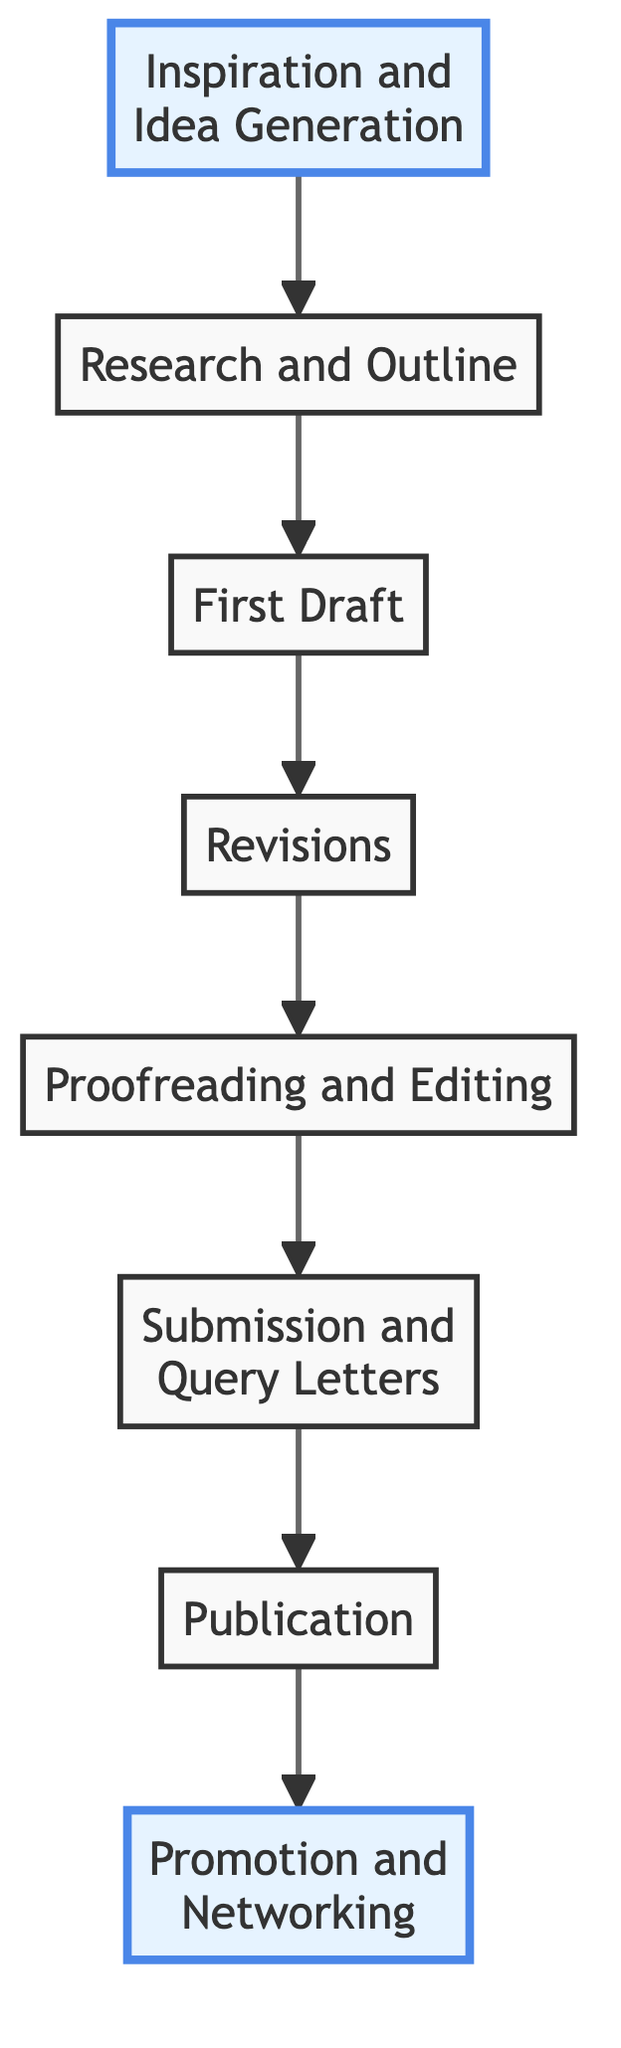What is the first step in the writing project process? The first step in the diagram is "Inspiration and Idea Generation." It is the topmost element, indicating the starting point of the writing project.
Answer: Inspiration and Idea Generation How many total steps are there in the writing project process? The diagram contains eight distinct nodes, each representing a step in the process, confirming that there are a total of eight steps.
Answer: 8 What follows after the "First Draft"? After "First Draft," the next step in the process is "Revisions." The arrows connecting the nodes illustrate the flow from one step to the next in the project.
Answer: Revisions Which two steps are highlighted in the diagram? The highlighted steps are "Inspiration and Idea Generation" and "Promotion and Networking." The diagram visually distinguishes these two nodes with a different color and stroke width.
Answer: Inspiration and Idea Generation, Promotion and Networking What step comes directly before "Submission and Query Letters"? The step that comes directly before "Submission and Query Letters" is "Proofreading and Editing." This relationship is shown by the arrow leading from "Proofreading and Editing" to "Submission and Query Letters."
Answer: Proofreading and Editing Is "Publication" immediately connected to "Research and Outline"? No, "Publication" is not immediately connected to "Research and Outline." The flow of the diagram indicates that the steps must go through "First Draft," "Revisions," "Proofreading and Editing," and "Submission and Query Letters" before reaching "Publication."
Answer: No How does "Promotion and Networking" relate to the other steps in the process? "Promotion and Networking" is the final step in the writing project process, represented as the last node in the diagram. It indicates that after publication, promotional activities and networking are essential.
Answer: Final step What is the main focus during the "First Draft"? The main focus during "First Draft" is on getting words down without worrying about perfection, emphasizing the importance of creativity and writing techniques.
Answer: Getting words down without worrying about perfection 